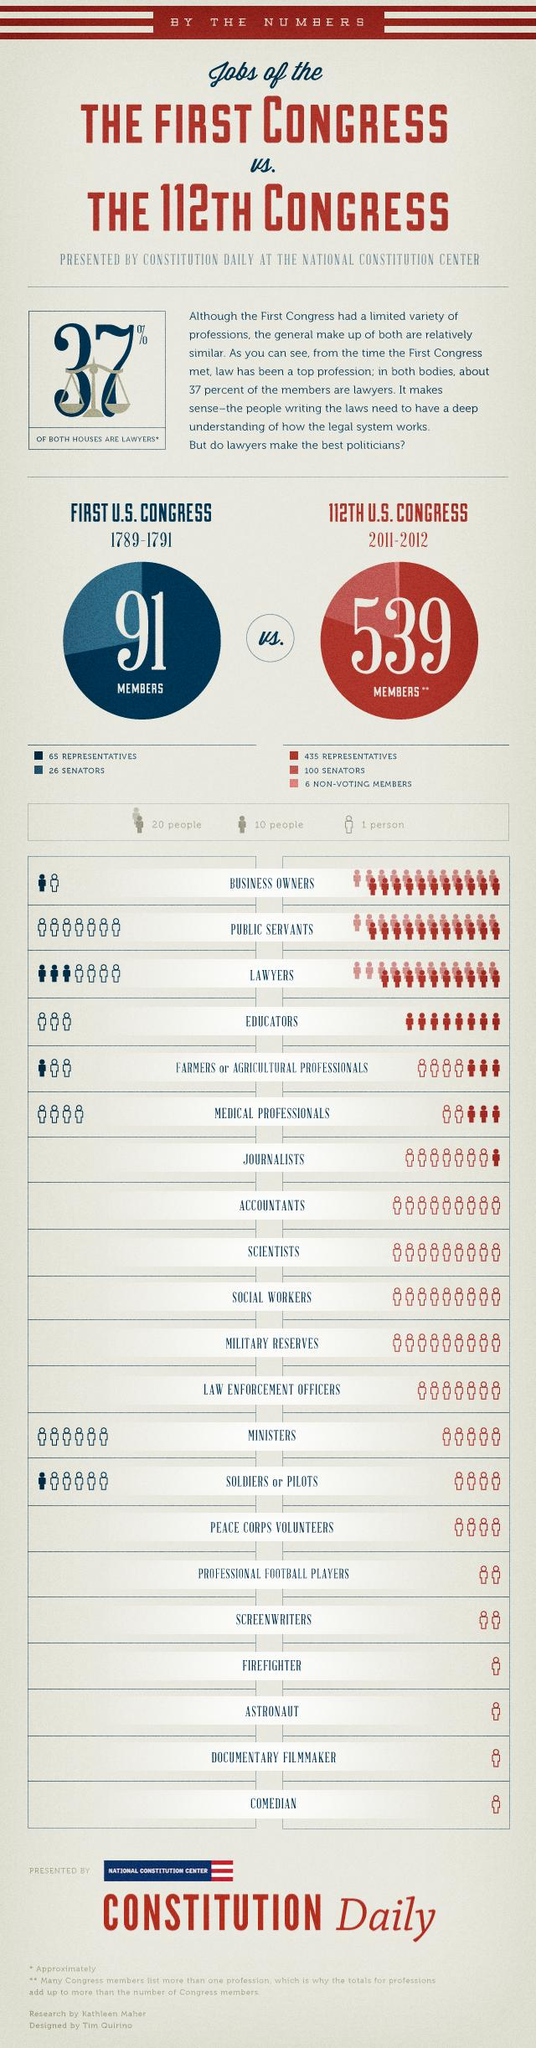Highlight a few significant elements in this photo. The number of educators in the first US congress was three. The total number of documentary film makers and screen writers in the 112th US congress was 3. The first US congress had 11 business owners. There were no comedians in the first US congress. In the 112th US Congress, there were a total of 26 social workers and journalists. 